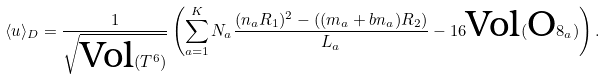<formula> <loc_0><loc_0><loc_500><loc_500>\langle u \rangle _ { D } = \frac { 1 } { \sqrt { \text {Vol} ( T ^ { 6 } ) } } \left ( \sum _ { a = 1 } ^ { K } N _ { a } \frac { ( n _ { a } R _ { 1 } ) ^ { 2 } - ( ( m _ { a } + b n _ { a } ) R _ { 2 } ) } { L _ { a } } - 1 6 \text {Vol} ( \text {O} 8 _ { a } ) \right ) .</formula> 